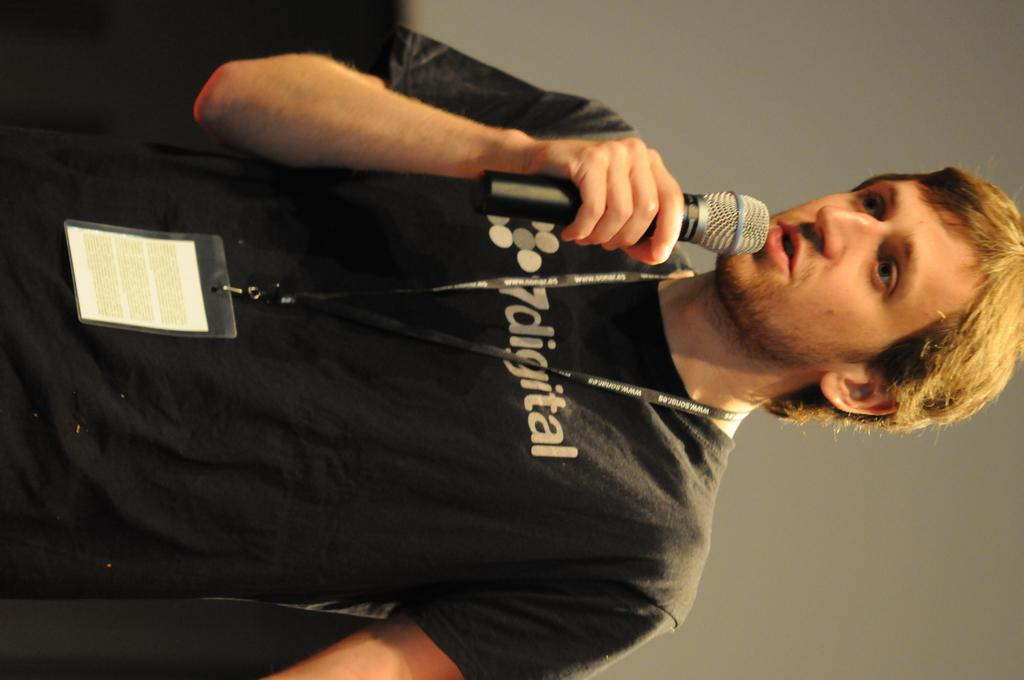What is the main subject of the image? There is a man in the image. What is the man doing in the image? The man is standing in the image. What is the man wearing? The man is wearing a black t-shirt. Does the man have any identification in the image? Yes, the man has an ID card. What object is the man holding in the image? The man is holding a microphone in his hands. What can be seen in the background of the image? There is a wall in the background of the image. Is the man sitting on a sofa in the image? No, the man is standing in the image, and there is no sofa present. What type of health issues is the man discussing in the image? There is no indication of any health issues being discussed in the image. 